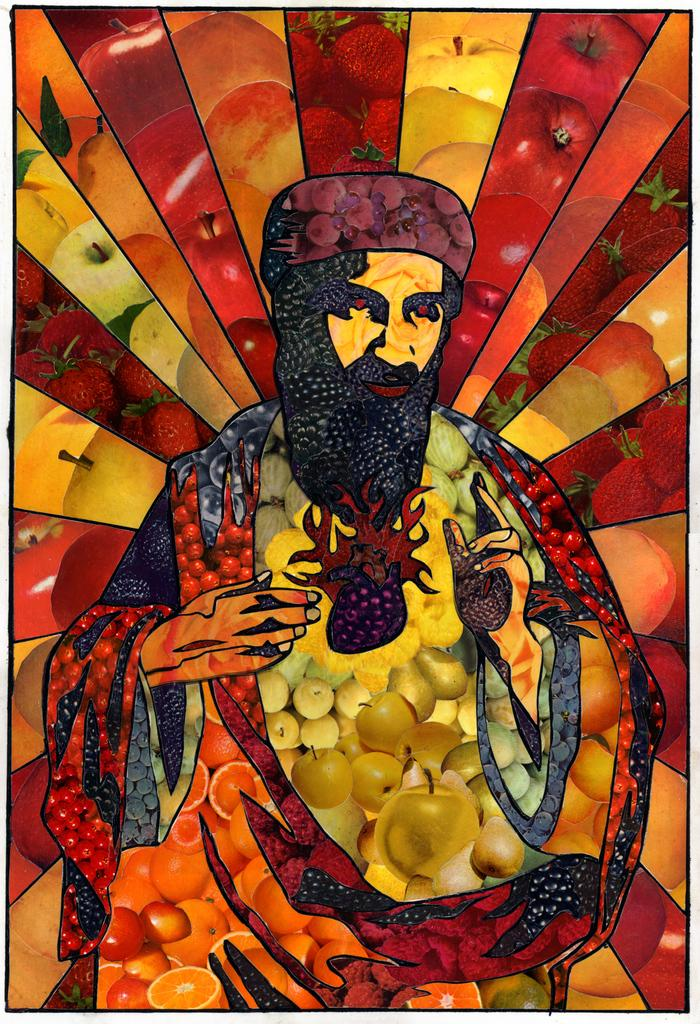What is the person in the image doing? There is a person sitting in the image. What types of fruits can be seen in the image? There are oranges, apples, berries, and other unspecified fruits in the image. How many mountains are visible in the image? There are no mountains visible in the image; it features a person sitting and various fruits. What type of corn is present in the image? There is no corn present in the image. 